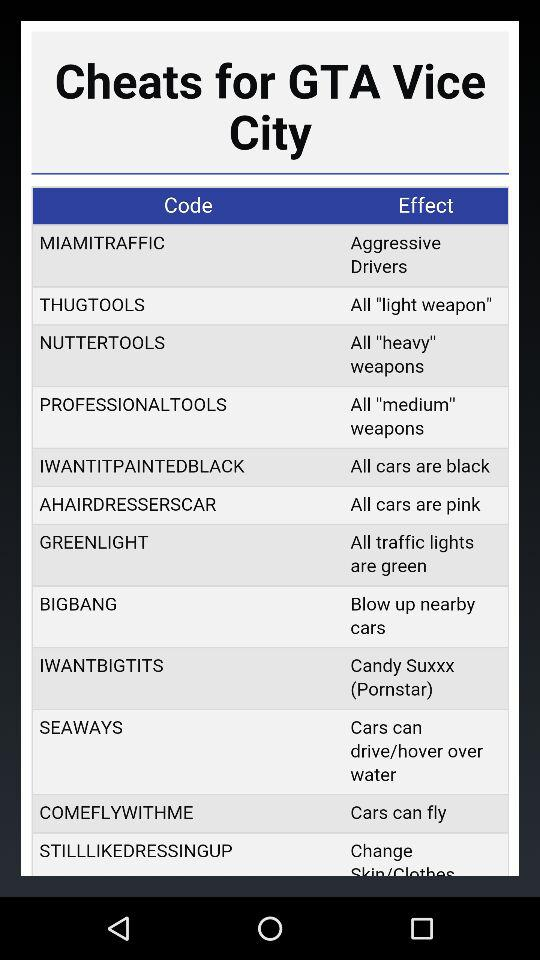What is the code for Thug tools?
When the provided information is insufficient, respond with <no answer>. <no answer> 